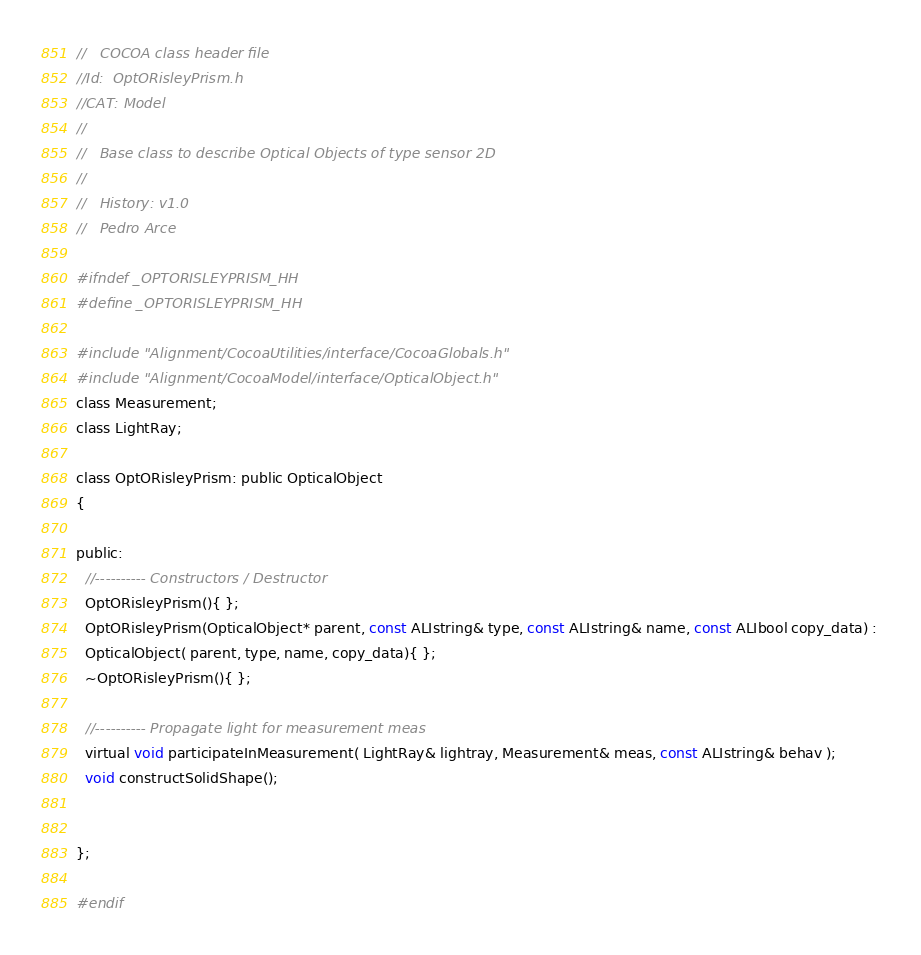Convert code to text. <code><loc_0><loc_0><loc_500><loc_500><_C_>//   COCOA class header file
//Id:  OptORisleyPrism.h
//CAT: Model
//
//   Base class to describe Optical Objects of type sensor 2D
// 
//   History: v1.0 
//   Pedro Arce

#ifndef _OPTORISLEYPRISM_HH
#define _OPTORISLEYPRISM_HH

#include "Alignment/CocoaUtilities/interface/CocoaGlobals.h"
#include "Alignment/CocoaModel/interface/OpticalObject.h"
class Measurement;
class LightRay;

class OptORisleyPrism: public OpticalObject
{

public:
  //---------- Constructors / Destructor
  OptORisleyPrism(){ };
  OptORisleyPrism(OpticalObject* parent, const ALIstring& type, const ALIstring& name, const ALIbool copy_data) : 
  OpticalObject( parent, type, name, copy_data){ };
  ~OptORisleyPrism(){ };

  //---------- Propagate light for measurement meas
  virtual void participateInMeasurement( LightRay& lightray, Measurement& meas, const ALIstring& behav );
  void constructSolidShape();


};

#endif

</code> 